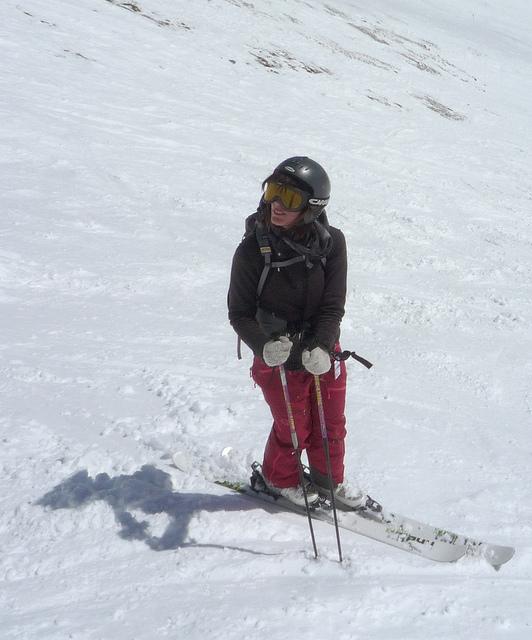Does the person have the ski poles on each side of her?
Keep it brief. No. Does this person have on gloves?
Be succinct. Yes. Is the woman using the poles for crutches?
Answer briefly. No. Does this person have good skiing form?
Answer briefly. No. 